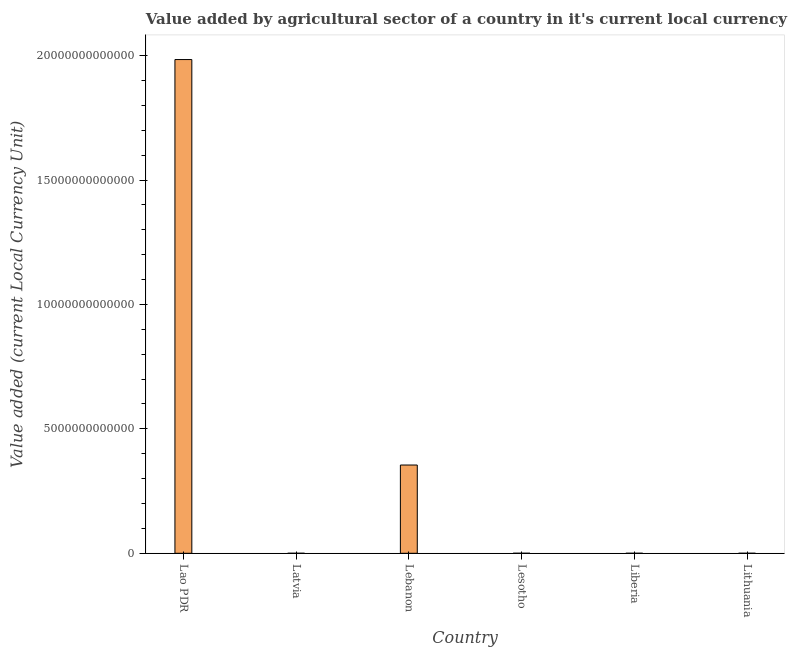Does the graph contain any zero values?
Provide a succinct answer. No. Does the graph contain grids?
Offer a very short reply. No. What is the title of the graph?
Your answer should be very brief. Value added by agricultural sector of a country in it's current local currency unit. What is the label or title of the X-axis?
Offer a terse response. Country. What is the label or title of the Y-axis?
Your response must be concise. Value added (current Local Currency Unit). What is the value added by agriculture sector in Liberia?
Provide a short and direct response. 6.73e+08. Across all countries, what is the maximum value added by agriculture sector?
Offer a terse response. 1.98e+13. Across all countries, what is the minimum value added by agriculture sector?
Provide a succinct answer. 6.73e+08. In which country was the value added by agriculture sector maximum?
Ensure brevity in your answer.  Lao PDR. In which country was the value added by agriculture sector minimum?
Make the answer very short. Liberia. What is the sum of the value added by agriculture sector?
Keep it short and to the point. 2.34e+13. What is the difference between the value added by agriculture sector in Latvia and Lithuania?
Make the answer very short. -6.24e+08. What is the average value added by agriculture sector per country?
Make the answer very short. 3.90e+12. What is the median value added by agriculture sector?
Offer a very short reply. 1.18e+09. What is the ratio of the value added by agriculture sector in Lao PDR to that in Lithuania?
Your answer should be compact. 1.48e+04. Is the value added by agriculture sector in Lao PDR less than that in Liberia?
Offer a very short reply. No. What is the difference between the highest and the second highest value added by agriculture sector?
Keep it short and to the point. 1.63e+13. What is the difference between the highest and the lowest value added by agriculture sector?
Provide a short and direct response. 1.98e+13. How many countries are there in the graph?
Make the answer very short. 6. What is the difference between two consecutive major ticks on the Y-axis?
Your response must be concise. 5.00e+12. What is the Value added (current Local Currency Unit) in Lao PDR?
Make the answer very short. 1.98e+13. What is the Value added (current Local Currency Unit) in Latvia?
Ensure brevity in your answer.  7.15e+08. What is the Value added (current Local Currency Unit) of Lebanon?
Provide a short and direct response. 3.55e+12. What is the Value added (current Local Currency Unit) of Lesotho?
Ensure brevity in your answer.  1.02e+09. What is the Value added (current Local Currency Unit) in Liberia?
Offer a very short reply. 6.73e+08. What is the Value added (current Local Currency Unit) of Lithuania?
Provide a succinct answer. 1.34e+09. What is the difference between the Value added (current Local Currency Unit) in Lao PDR and Latvia?
Give a very brief answer. 1.98e+13. What is the difference between the Value added (current Local Currency Unit) in Lao PDR and Lebanon?
Your answer should be very brief. 1.63e+13. What is the difference between the Value added (current Local Currency Unit) in Lao PDR and Lesotho?
Provide a short and direct response. 1.98e+13. What is the difference between the Value added (current Local Currency Unit) in Lao PDR and Liberia?
Your answer should be very brief. 1.98e+13. What is the difference between the Value added (current Local Currency Unit) in Lao PDR and Lithuania?
Keep it short and to the point. 1.98e+13. What is the difference between the Value added (current Local Currency Unit) in Latvia and Lebanon?
Your answer should be compact. -3.55e+12. What is the difference between the Value added (current Local Currency Unit) in Latvia and Lesotho?
Keep it short and to the point. -3.09e+08. What is the difference between the Value added (current Local Currency Unit) in Latvia and Liberia?
Ensure brevity in your answer.  4.21e+07. What is the difference between the Value added (current Local Currency Unit) in Latvia and Lithuania?
Provide a short and direct response. -6.24e+08. What is the difference between the Value added (current Local Currency Unit) in Lebanon and Lesotho?
Provide a succinct answer. 3.55e+12. What is the difference between the Value added (current Local Currency Unit) in Lebanon and Liberia?
Give a very brief answer. 3.55e+12. What is the difference between the Value added (current Local Currency Unit) in Lebanon and Lithuania?
Provide a short and direct response. 3.55e+12. What is the difference between the Value added (current Local Currency Unit) in Lesotho and Liberia?
Provide a short and direct response. 3.51e+08. What is the difference between the Value added (current Local Currency Unit) in Lesotho and Lithuania?
Keep it short and to the point. -3.15e+08. What is the difference between the Value added (current Local Currency Unit) in Liberia and Lithuania?
Offer a terse response. -6.66e+08. What is the ratio of the Value added (current Local Currency Unit) in Lao PDR to that in Latvia?
Make the answer very short. 2.77e+04. What is the ratio of the Value added (current Local Currency Unit) in Lao PDR to that in Lebanon?
Offer a very short reply. 5.59. What is the ratio of the Value added (current Local Currency Unit) in Lao PDR to that in Lesotho?
Offer a very short reply. 1.94e+04. What is the ratio of the Value added (current Local Currency Unit) in Lao PDR to that in Liberia?
Provide a short and direct response. 2.95e+04. What is the ratio of the Value added (current Local Currency Unit) in Lao PDR to that in Lithuania?
Offer a terse response. 1.48e+04. What is the ratio of the Value added (current Local Currency Unit) in Latvia to that in Lesotho?
Your response must be concise. 0.7. What is the ratio of the Value added (current Local Currency Unit) in Latvia to that in Liberia?
Make the answer very short. 1.06. What is the ratio of the Value added (current Local Currency Unit) in Latvia to that in Lithuania?
Your answer should be compact. 0.53. What is the ratio of the Value added (current Local Currency Unit) in Lebanon to that in Lesotho?
Offer a terse response. 3461.95. What is the ratio of the Value added (current Local Currency Unit) in Lebanon to that in Liberia?
Your answer should be compact. 5268.03. What is the ratio of the Value added (current Local Currency Unit) in Lebanon to that in Lithuania?
Ensure brevity in your answer.  2647.66. What is the ratio of the Value added (current Local Currency Unit) in Lesotho to that in Liberia?
Ensure brevity in your answer.  1.52. What is the ratio of the Value added (current Local Currency Unit) in Lesotho to that in Lithuania?
Your response must be concise. 0.77. What is the ratio of the Value added (current Local Currency Unit) in Liberia to that in Lithuania?
Make the answer very short. 0.5. 